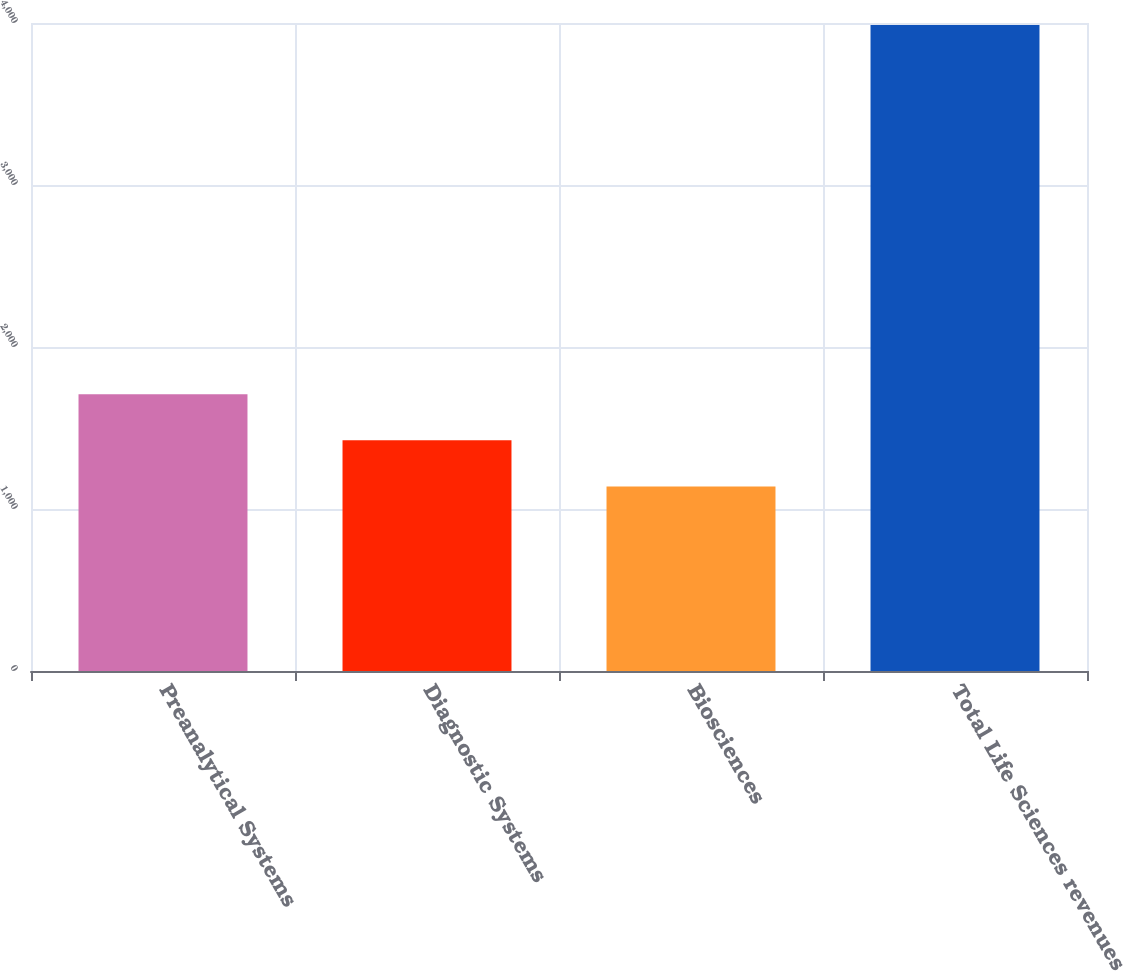Convert chart to OTSL. <chart><loc_0><loc_0><loc_500><loc_500><bar_chart><fcel>Preanalytical Systems<fcel>Diagnostic Systems<fcel>Biosciences<fcel>Total Life Sciences revenues<nl><fcel>1708.8<fcel>1423.9<fcel>1139<fcel>3988<nl></chart> 